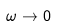<formula> <loc_0><loc_0><loc_500><loc_500>\omega \rightarrow 0</formula> 